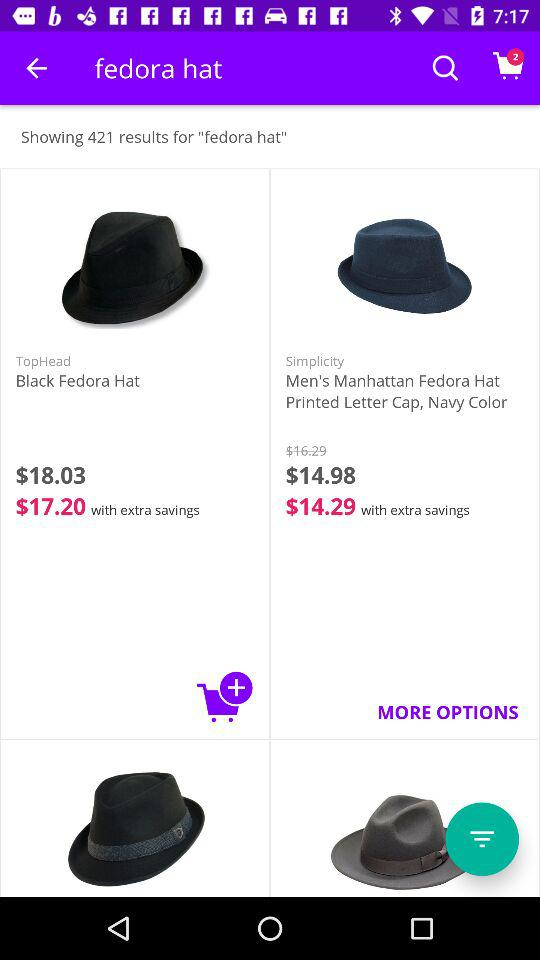What is the price of "Men's Manhattan Fedora Hat Printed Letter Cap" after extra savings? The price is $14.29. 